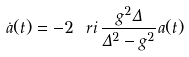<formula> <loc_0><loc_0><loc_500><loc_500>\dot { a } ( t ) = - 2 \ r i \, \frac { g ^ { 2 } \Delta } { \Delta ^ { 2 } - g ^ { 2 } } a ( t )</formula> 